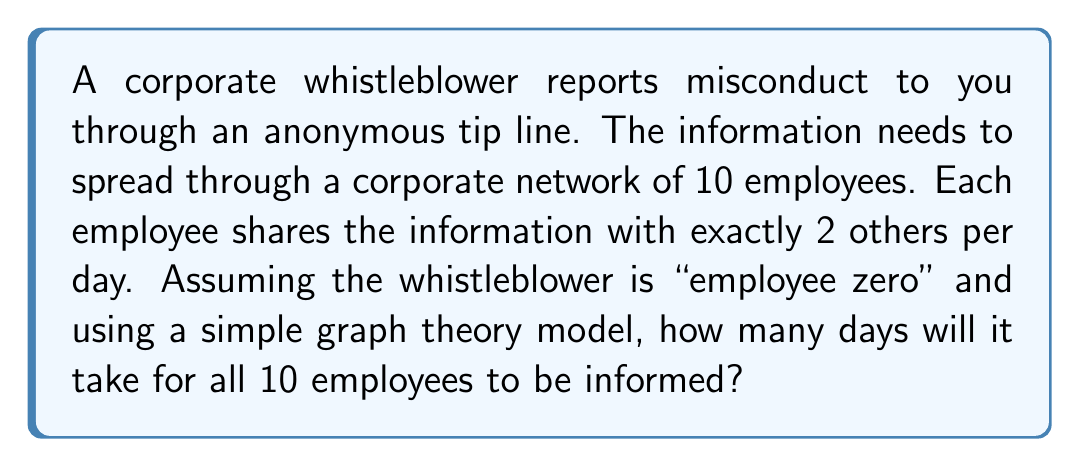What is the answer to this math problem? Let's approach this step-by-step using graph theory:

1) We can model this situation as a graph where employees are nodes and information sharing creates edges.

2) On day 0, only the whistleblower (employee zero) knows the information.

3) Let $I_n$ be the number of informed employees on day $n$.

4) Each day, every informed employee shares with 2 new people. However, we need to account for potential overlap.

5) The maximum number of newly informed employees on day $n$ is:

   $$\text{New}_n = \min(2I_{n-1}, 10 - I_{n-1})$$

6) Therefore, the recurrence relation is:

   $$I_n = I_{n-1} + \min(2I_{n-1}, 10 - I_{n-1})$$

7) Let's calculate day by day:

   Day 0: $I_0 = 1$ (whistleblower)
   Day 1: $I_1 = 1 + \min(2(1), 10-1) = 3$
   Day 2: $I_2 = 3 + \min(2(3), 10-3) = 7$
   Day 3: $I_3 = 7 + \min(2(7), 10-7) = 10$

8) On day 3, all 10 employees are informed.
Answer: 3 days 